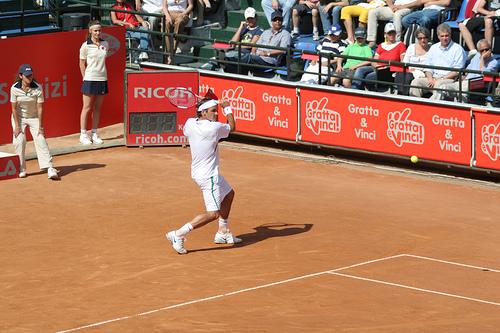What are they playing?
Give a very brief answer. Tennis. What color are the walls?
Be succinct. Red. How many fans are there?
Give a very brief answer. 20. 